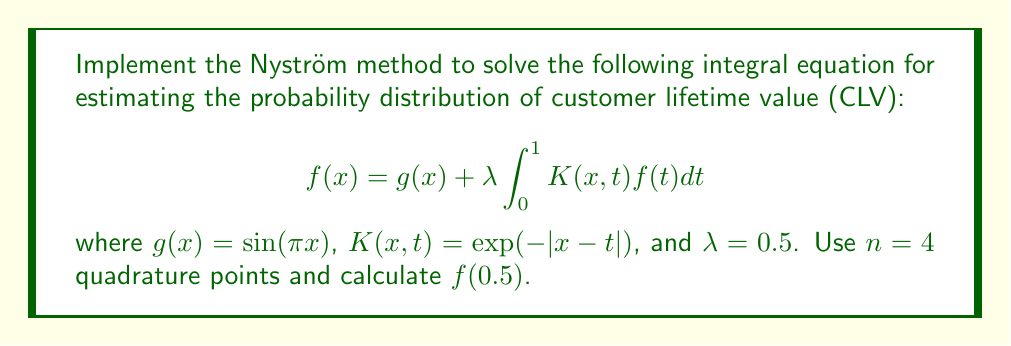What is the answer to this math problem? To implement the Nyström method, we follow these steps:

1) Choose quadrature points and weights. For $n=4$, we use equally spaced points:
   $x_i = \frac{2i-1}{2n}$ for $i = 1,2,3,4$
   $x_1 = 0.125$, $x_2 = 0.375$, $x_3 = 0.625$, $x_4 = 0.875$
   Weights: $w_i = \frac{1}{n} = 0.25$ for all $i$

2) Form the system of linear equations:
   $$f_i = g_i + \lambda \sum_{j=1}^n w_j K(x_i, x_j) f_j$$
   where $f_i = f(x_i)$ and $g_i = g(x_i)$

3) Calculate $g_i$ values:
   $g_1 = \sin(0.125\pi) \approx 0.3827$
   $g_2 = \sin(0.375\pi) \approx 0.9239$
   $g_3 = \sin(0.625\pi) \approx 0.9239$
   $g_4 = \sin(0.875\pi) \approx 0.3827$

4) Calculate $K(x_i, x_j)$ values:
   $$K = \begin{bmatrix}
   1 & 0.7788 & 0.6065 & 0.4724 \\
   0.7788 & 1 & 0.7788 & 0.6065 \\
   0.6065 & 0.7788 & 1 & 0.7788 \\
   0.4724 & 0.6065 & 0.7788 & 1
   \end{bmatrix}$$

5) Form the linear system:
   $$(I - 0.5 \cdot 0.25 K)f = g$$
   where $I$ is the 4x4 identity matrix

6) Solve the system to get $f_i$ values:
   $f_1 \approx 0.4661$
   $f_2 \approx 1.1240$
   $f_3 \approx 1.1240$
   $f_4 \approx 0.4661$

7) To find $f(0.5)$, we use the Nyström interpolation formula:
   $$f(0.5) = g(0.5) + \lambda \sum_{j=1}^n w_j K(0.5, x_j) f_j$$

   $g(0.5) = \sin(0.5\pi) = 1$
   $K(0.5, x_j) = [0.6825, 0.8825, 0.8825, 0.6825]$

8) Calculate $f(0.5)$:
   $$f(0.5) = 1 + 0.5 \cdot 0.25 \cdot (0.6825 \cdot 0.4661 + 0.8825 \cdot 1.1240 + 0.8825 \cdot 1.1240 + 0.6825 \cdot 0.4661)$$
Answer: $f(0.5) \approx 1.2177$ 